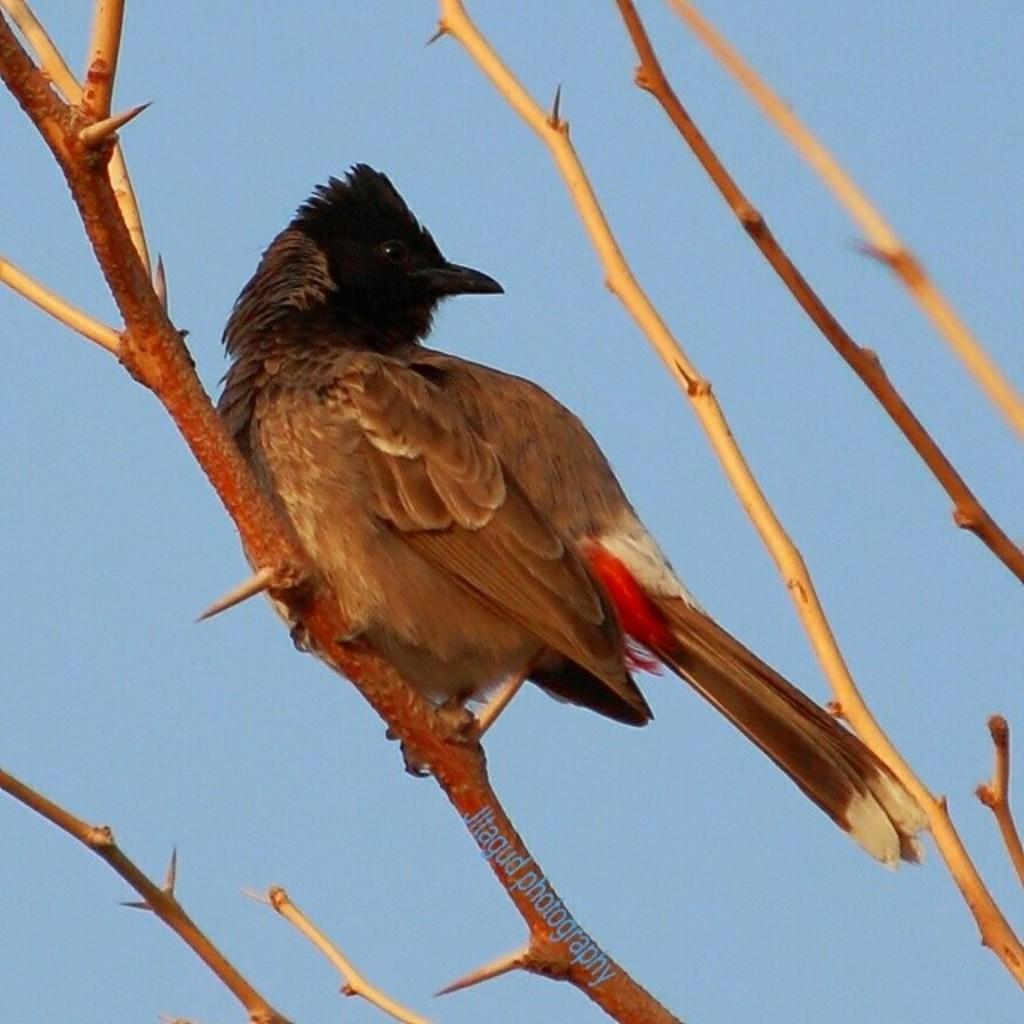What type of animal can be seen in the image? There is a bird in the image. What is the bird perched on in the image? The bird is perched on branches of a tree in the image. What can be seen in the background of the image? The sky is visible in the image. What type of wealth is the bird holding in its beak in the image? There is no indication in the image that the bird is holding any wealth; it is simply perched on the branches of a tree. 